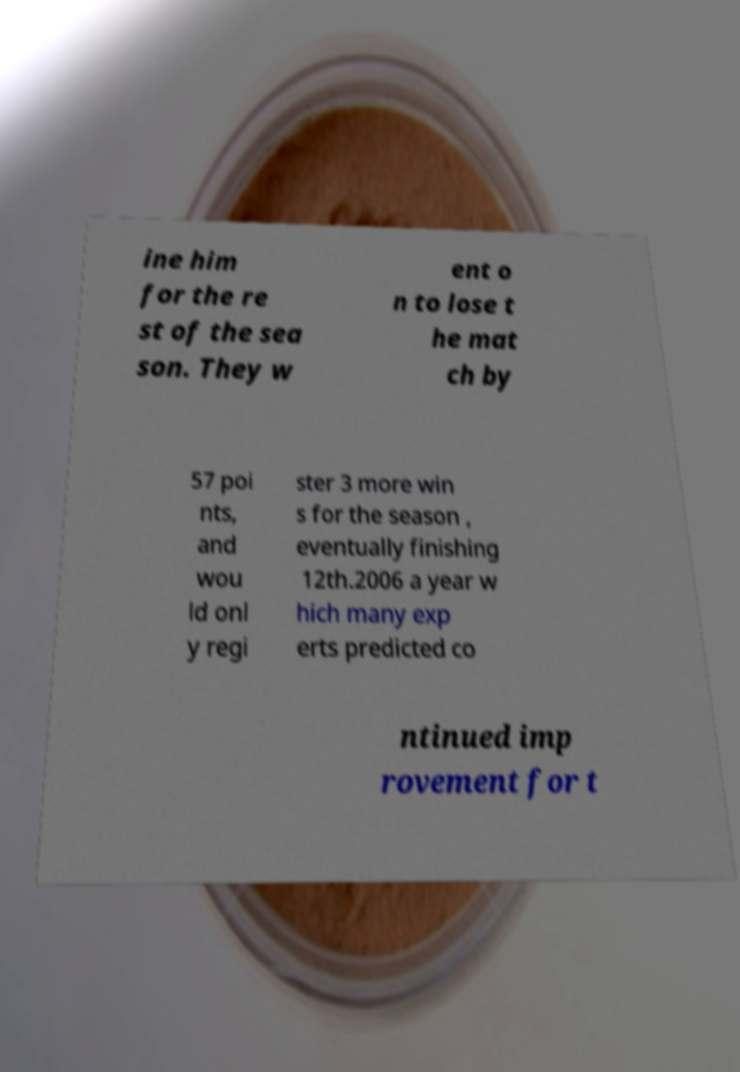Please identify and transcribe the text found in this image. ine him for the re st of the sea son. They w ent o n to lose t he mat ch by 57 poi nts, and wou ld onl y regi ster 3 more win s for the season , eventually finishing 12th.2006 a year w hich many exp erts predicted co ntinued imp rovement for t 